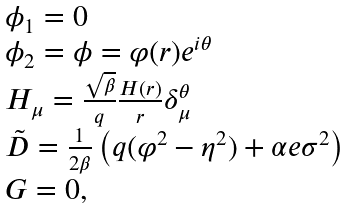Convert formula to latex. <formula><loc_0><loc_0><loc_500><loc_500>\begin{array} { l l } { { \phi _ { 1 } = 0 } } \\ { { \phi _ { 2 } = \phi = \varphi ( r ) e ^ { i \theta } } } \\ { { H _ { \mu } = \frac { \sqrt { \beta } } { q } \frac { H ( r ) } { r } \delta _ { \mu } ^ { \theta } } } \\ { { \tilde { D } = \frac { 1 } { 2 \beta } \left ( q ( \varphi ^ { 2 } - \eta ^ { 2 } ) + \alpha e \sigma ^ { 2 } \right ) } } \\ { G = 0 , } \end{array}</formula> 